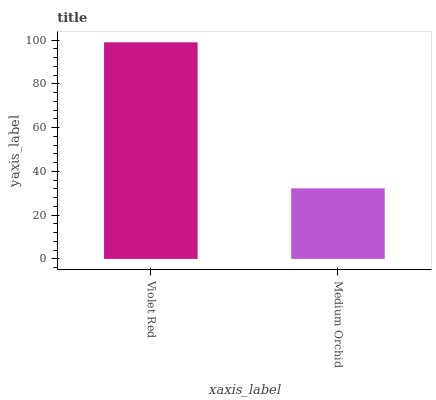Is Medium Orchid the minimum?
Answer yes or no. Yes. Is Violet Red the maximum?
Answer yes or no. Yes. Is Medium Orchid the maximum?
Answer yes or no. No. Is Violet Red greater than Medium Orchid?
Answer yes or no. Yes. Is Medium Orchid less than Violet Red?
Answer yes or no. Yes. Is Medium Orchid greater than Violet Red?
Answer yes or no. No. Is Violet Red less than Medium Orchid?
Answer yes or no. No. Is Violet Red the high median?
Answer yes or no. Yes. Is Medium Orchid the low median?
Answer yes or no. Yes. Is Medium Orchid the high median?
Answer yes or no. No. Is Violet Red the low median?
Answer yes or no. No. 